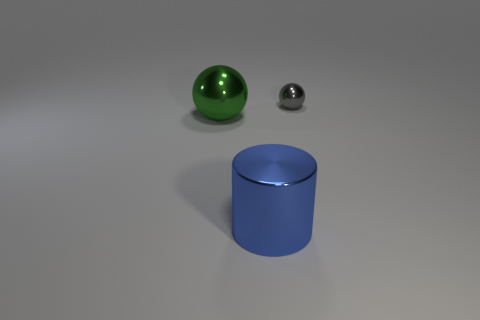Add 2 big balls. How many objects exist? 5 Subtract all spheres. How many objects are left? 1 Subtract 1 balls. How many balls are left? 1 Subtract 0 green cylinders. How many objects are left? 3 Subtract all green cylinders. Subtract all blue cubes. How many cylinders are left? 1 Subtract all brown cylinders. How many gray balls are left? 1 Subtract all big shiny balls. Subtract all large green metal balls. How many objects are left? 1 Add 1 small gray metal things. How many small gray metal things are left? 2 Add 1 blue matte cylinders. How many blue matte cylinders exist? 1 